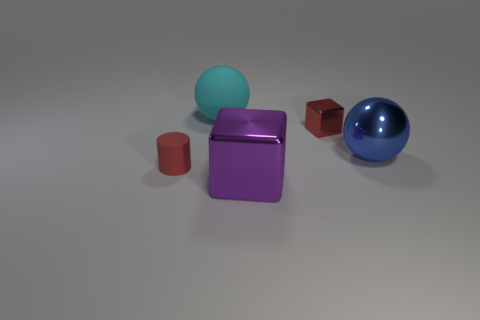Could you guess the context or purpose of this arrangement? The context of the arrangement isn't immediately clear, but it could be part of a visual composition meant to demonstrate differences in color, material, and size. It might also be an abstract configuration designed for a stylistic display or an educational purpose to help distinguish between shapes and textures. 